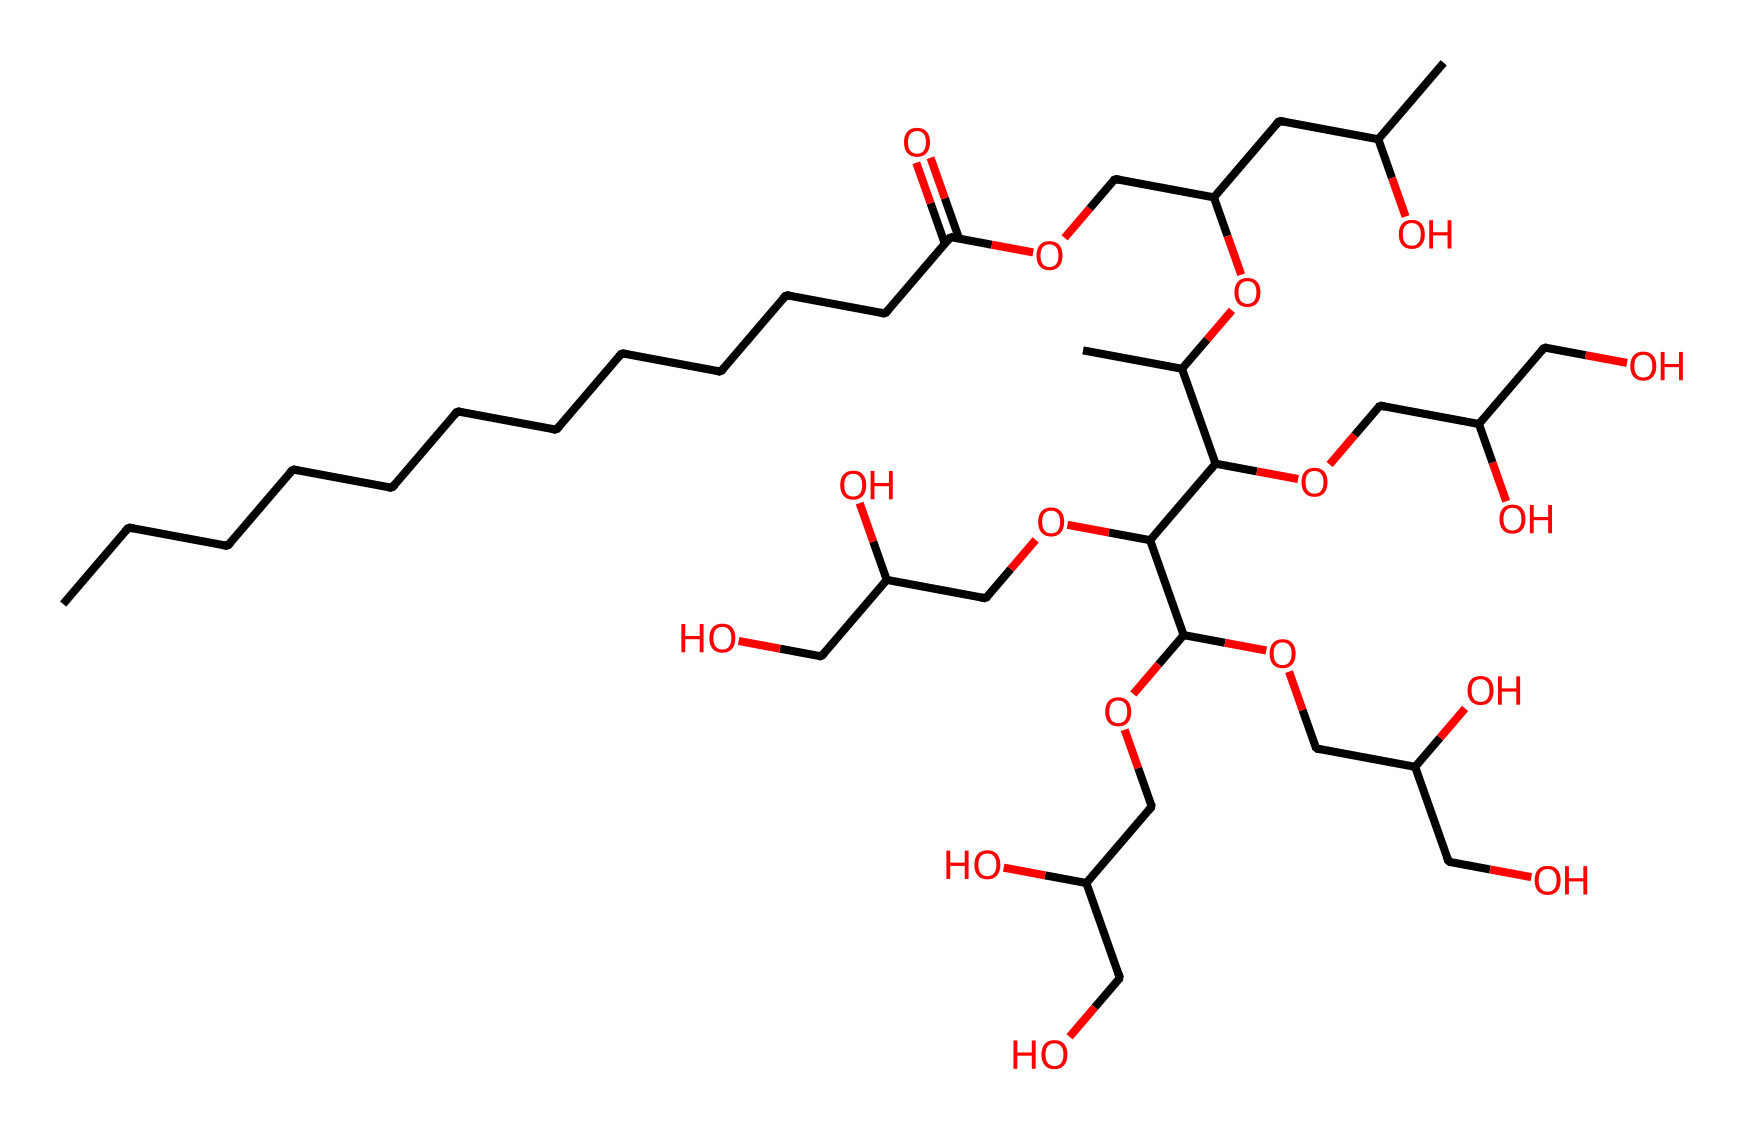What is the longest carbon chain in polysorbate 20? The chemical provided contains a long carbon chain that can be identified by counting the number of consecutive carbon atoms present. The longest chain is indicated by the structure at the left of the SMILES, showing 12 carbon atoms in a continuous line.
Answer: 12 How many hydroxyl (–OH) groups are present in polysorbate 20? By analyzing the structure, we can identify the hydroxyl groups based on the presence of oxygen atoms bonded to hydrogen at different points in the molecule. There are 6 –OH groups scattered throughout the structure.
Answer: 6 Is polysorbate 20 considered a nonionic surfactant? Nonionic surfactants are characterized by the absence of charged groups in their structure. Since polysorbate 20 lacks ionizable groups, it is classified as nonionic.
Answer: yes What role do the ester linkages play in the structure of polysorbate 20? Ester linkages, formed between fatty acids and alcohols, are significant in surfactants as they influence solubility, surfactant properties, and emulsification. In polysorbate 20, they connect the fatty acid tail to the hydrophilic portions, enhancing its effectiveness.
Answer: emulsification How many distinct structural units are visible in polysorbate 20? Upon reviewing the SMILES structure, polysorbate 20 exhibits a complex arrangement with distinct hydrophobic and hydrophilic segments that can be counted as separate structural units. In total, there are 5 notable structural units present.
Answer: 5 